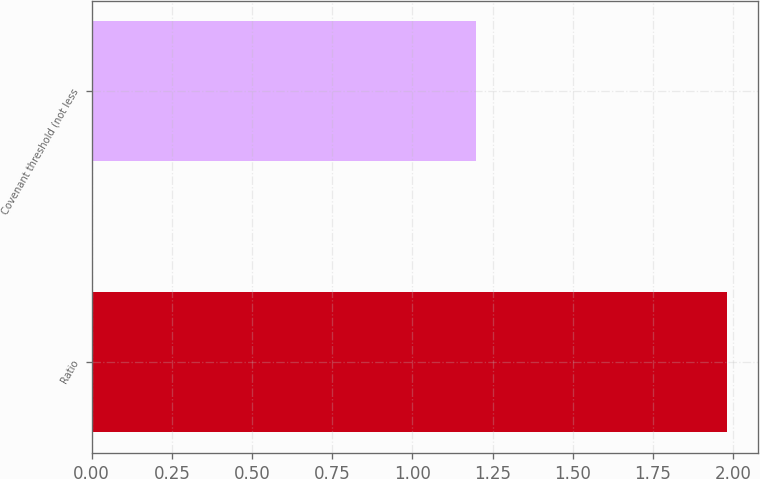Convert chart. <chart><loc_0><loc_0><loc_500><loc_500><bar_chart><fcel>Ratio<fcel>Covenant threshold (not less<nl><fcel>1.98<fcel>1.2<nl></chart> 